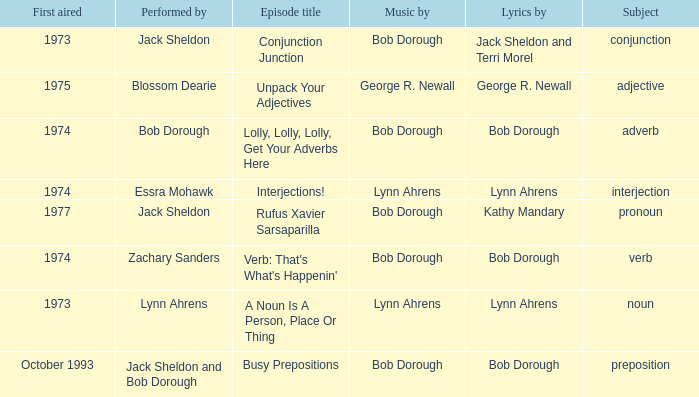I'm looking to parse the entire table for insights. Could you assist me with that? {'header': ['First aired', 'Performed by', 'Episode title', 'Music by', 'Lyrics by', 'Subject'], 'rows': [['1973', 'Jack Sheldon', 'Conjunction Junction', 'Bob Dorough', 'Jack Sheldon and Terri Morel', 'conjunction'], ['1975', 'Blossom Dearie', 'Unpack Your Adjectives', 'George R. Newall', 'George R. Newall', 'adjective'], ['1974', 'Bob Dorough', 'Lolly, Lolly, Lolly, Get Your Adverbs Here', 'Bob Dorough', 'Bob Dorough', 'adverb'], ['1974', 'Essra Mohawk', 'Interjections!', 'Lynn Ahrens', 'Lynn Ahrens', 'interjection'], ['1977', 'Jack Sheldon', 'Rufus Xavier Sarsaparilla', 'Bob Dorough', 'Kathy Mandary', 'pronoun'], ['1974', 'Zachary Sanders', "Verb: That's What's Happenin'", 'Bob Dorough', 'Bob Dorough', 'verb'], ['1973', 'Lynn Ahrens', 'A Noun Is A Person, Place Or Thing', 'Lynn Ahrens', 'Lynn Ahrens', 'noun'], ['October 1993', 'Jack Sheldon and Bob Dorough', 'Busy Prepositions', 'Bob Dorough', 'Bob Dorough', 'preposition']]} When the topic is interjection, how many actors are present? 1.0. 